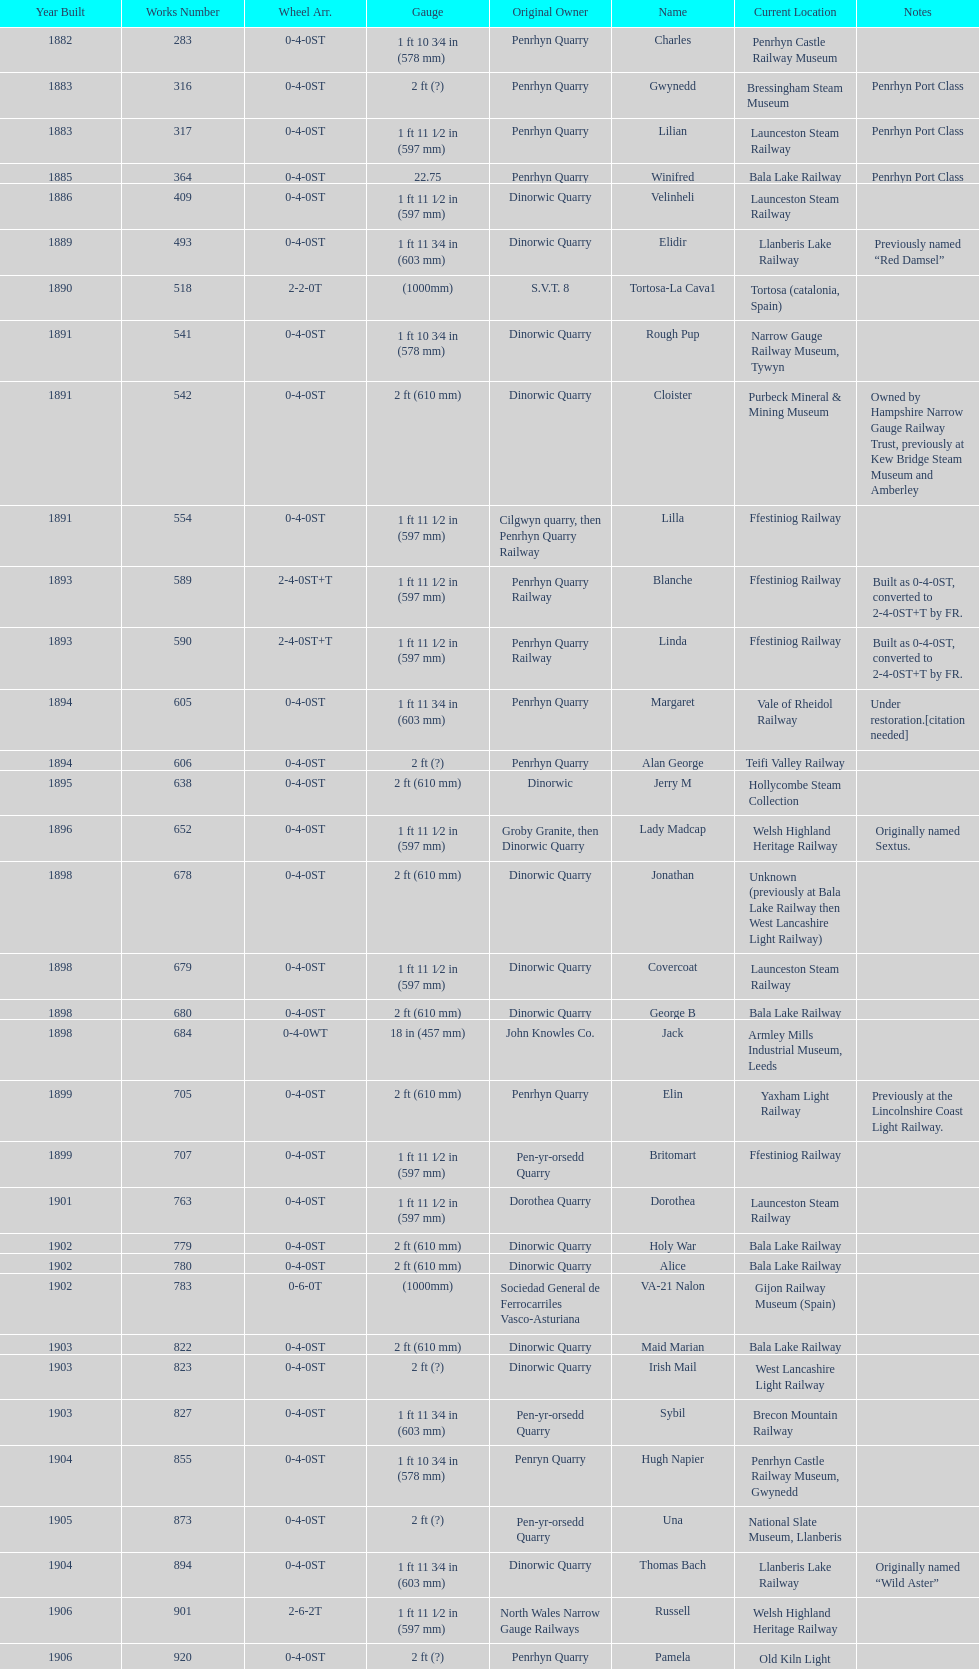Which works number had a larger gauge, 283 or 317? 317. 